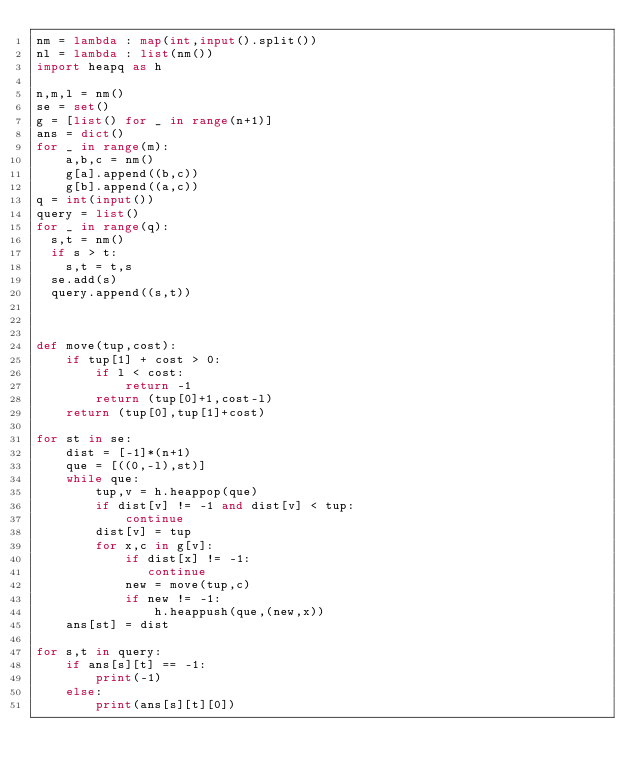Convert code to text. <code><loc_0><loc_0><loc_500><loc_500><_Python_>nm = lambda : map(int,input().split())
nl = lambda : list(nm())
import heapq as h

n,m,l = nm()
se = set()
g = [list() for _ in range(n+1)]
ans = dict()
for _ in range(m):
    a,b,c = nm()
    g[a].append((b,c))
    g[b].append((a,c))
q = int(input())
query = list()
for _ in range(q):
  s,t = nm()
  if s > t:
    s,t = t,s
  se.add(s)
  query.append((s,t))
  


def move(tup,cost):
    if tup[1] + cost > 0:
        if l < cost:
            return -1
        return (tup[0]+1,cost-l)
    return (tup[0],tup[1]+cost)

for st in se:
    dist = [-1]*(n+1)
    que = [((0,-l),st)]
    while que:
        tup,v = h.heappop(que)
        if dist[v] != -1 and dist[v] < tup:
            continue
        dist[v] = tup
        for x,c in g[v]:
            if dist[x] != -1:
               continue
            new = move(tup,c)
            if new != -1:
                h.heappush(que,(new,x))
    ans[st] = dist

for s,t in query:
    if ans[s][t] == -1:
        print(-1)
    else:
        print(ans[s][t][0]) 
 </code> 